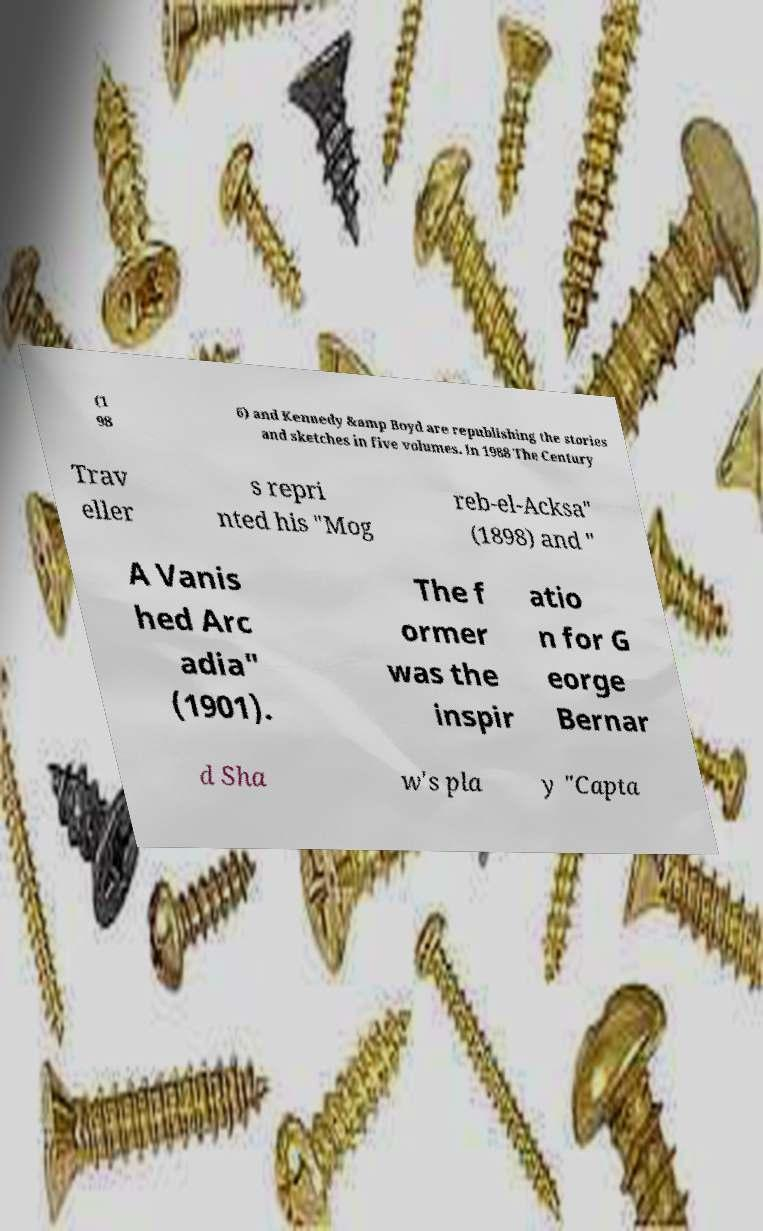Please identify and transcribe the text found in this image. (1 98 6) and Kennedy &amp Boyd are republishing the stories and sketches in five volumes. In 1988 The Century Trav eller s repri nted his "Mog reb-el-Acksa" (1898) and " A Vanis hed Arc adia" (1901). The f ormer was the inspir atio n for G eorge Bernar d Sha w's pla y "Capta 